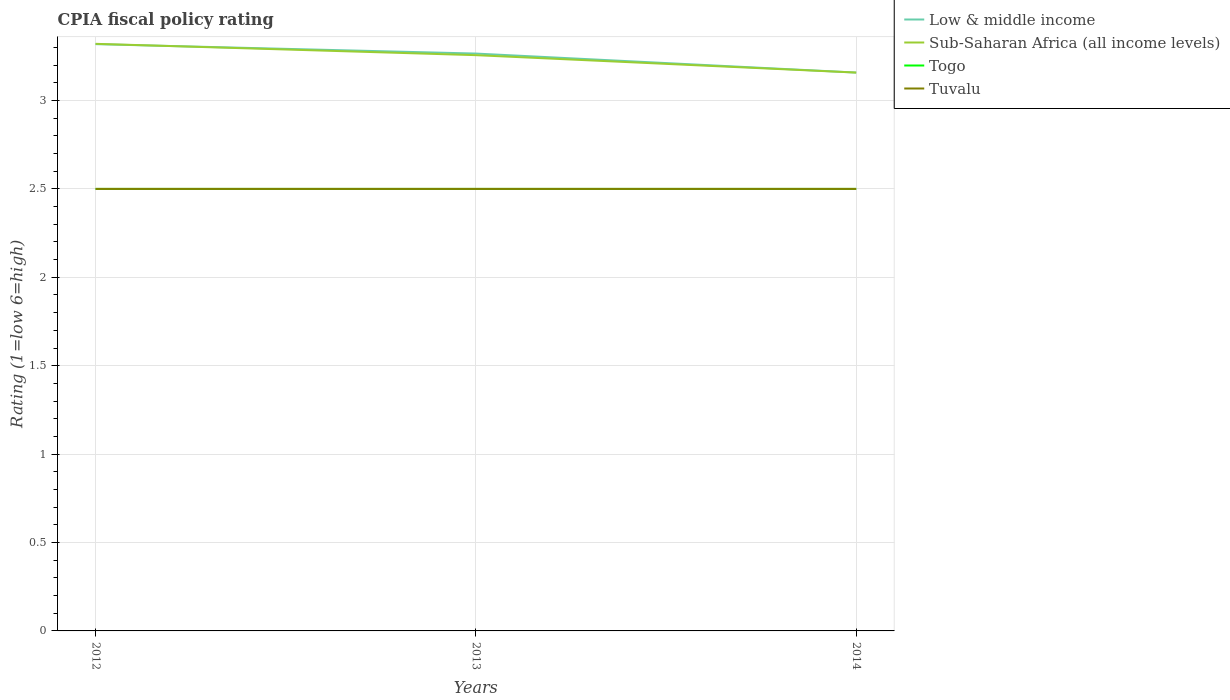Across all years, what is the maximum CPIA rating in Sub-Saharan Africa (all income levels)?
Give a very brief answer. 3.16. In which year was the CPIA rating in Low & middle income maximum?
Your answer should be very brief. 2014. What is the total CPIA rating in Togo in the graph?
Make the answer very short. 0. What is the difference between the highest and the second highest CPIA rating in Low & middle income?
Provide a short and direct response. 0.16. What is the difference between the highest and the lowest CPIA rating in Low & middle income?
Offer a very short reply. 2. How many lines are there?
Provide a succinct answer. 4. How many years are there in the graph?
Keep it short and to the point. 3. Are the values on the major ticks of Y-axis written in scientific E-notation?
Your answer should be compact. No. Does the graph contain grids?
Give a very brief answer. Yes. How many legend labels are there?
Ensure brevity in your answer.  4. What is the title of the graph?
Your answer should be compact. CPIA fiscal policy rating. What is the label or title of the Y-axis?
Your answer should be compact. Rating (1=low 6=high). What is the Rating (1=low 6=high) in Low & middle income in 2012?
Your response must be concise. 3.32. What is the Rating (1=low 6=high) in Sub-Saharan Africa (all income levels) in 2012?
Your answer should be very brief. 3.32. What is the Rating (1=low 6=high) in Tuvalu in 2012?
Your answer should be very brief. 2.5. What is the Rating (1=low 6=high) in Low & middle income in 2013?
Your answer should be very brief. 3.27. What is the Rating (1=low 6=high) in Sub-Saharan Africa (all income levels) in 2013?
Provide a short and direct response. 3.26. What is the Rating (1=low 6=high) in Togo in 2013?
Give a very brief answer. 2.5. What is the Rating (1=low 6=high) of Tuvalu in 2013?
Provide a short and direct response. 2.5. What is the Rating (1=low 6=high) of Low & middle income in 2014?
Keep it short and to the point. 3.16. What is the Rating (1=low 6=high) of Sub-Saharan Africa (all income levels) in 2014?
Provide a succinct answer. 3.16. What is the Rating (1=low 6=high) in Tuvalu in 2014?
Keep it short and to the point. 2.5. Across all years, what is the maximum Rating (1=low 6=high) in Low & middle income?
Provide a succinct answer. 3.32. Across all years, what is the maximum Rating (1=low 6=high) of Sub-Saharan Africa (all income levels)?
Your response must be concise. 3.32. Across all years, what is the maximum Rating (1=low 6=high) of Tuvalu?
Ensure brevity in your answer.  2.5. Across all years, what is the minimum Rating (1=low 6=high) in Low & middle income?
Give a very brief answer. 3.16. Across all years, what is the minimum Rating (1=low 6=high) of Sub-Saharan Africa (all income levels)?
Your answer should be compact. 3.16. What is the total Rating (1=low 6=high) of Low & middle income in the graph?
Make the answer very short. 9.74. What is the total Rating (1=low 6=high) in Sub-Saharan Africa (all income levels) in the graph?
Offer a terse response. 9.73. What is the total Rating (1=low 6=high) in Tuvalu in the graph?
Provide a short and direct response. 7.5. What is the difference between the Rating (1=low 6=high) in Low & middle income in 2012 and that in 2013?
Keep it short and to the point. 0.05. What is the difference between the Rating (1=low 6=high) of Sub-Saharan Africa (all income levels) in 2012 and that in 2013?
Make the answer very short. 0.06. What is the difference between the Rating (1=low 6=high) in Togo in 2012 and that in 2013?
Your answer should be compact. 0. What is the difference between the Rating (1=low 6=high) of Low & middle income in 2012 and that in 2014?
Provide a short and direct response. 0.16. What is the difference between the Rating (1=low 6=high) of Sub-Saharan Africa (all income levels) in 2012 and that in 2014?
Make the answer very short. 0.16. What is the difference between the Rating (1=low 6=high) in Low & middle income in 2013 and that in 2014?
Make the answer very short. 0.11. What is the difference between the Rating (1=low 6=high) in Sub-Saharan Africa (all income levels) in 2013 and that in 2014?
Offer a very short reply. 0.1. What is the difference between the Rating (1=low 6=high) in Togo in 2013 and that in 2014?
Provide a short and direct response. 0. What is the difference between the Rating (1=low 6=high) of Low & middle income in 2012 and the Rating (1=low 6=high) of Sub-Saharan Africa (all income levels) in 2013?
Provide a short and direct response. 0.06. What is the difference between the Rating (1=low 6=high) in Low & middle income in 2012 and the Rating (1=low 6=high) in Togo in 2013?
Give a very brief answer. 0.82. What is the difference between the Rating (1=low 6=high) in Low & middle income in 2012 and the Rating (1=low 6=high) in Tuvalu in 2013?
Your answer should be very brief. 0.82. What is the difference between the Rating (1=low 6=high) of Sub-Saharan Africa (all income levels) in 2012 and the Rating (1=low 6=high) of Togo in 2013?
Offer a very short reply. 0.82. What is the difference between the Rating (1=low 6=high) in Sub-Saharan Africa (all income levels) in 2012 and the Rating (1=low 6=high) in Tuvalu in 2013?
Keep it short and to the point. 0.82. What is the difference between the Rating (1=low 6=high) of Togo in 2012 and the Rating (1=low 6=high) of Tuvalu in 2013?
Give a very brief answer. 0. What is the difference between the Rating (1=low 6=high) of Low & middle income in 2012 and the Rating (1=low 6=high) of Sub-Saharan Africa (all income levels) in 2014?
Make the answer very short. 0.16. What is the difference between the Rating (1=low 6=high) in Low & middle income in 2012 and the Rating (1=low 6=high) in Togo in 2014?
Provide a short and direct response. 0.82. What is the difference between the Rating (1=low 6=high) of Low & middle income in 2012 and the Rating (1=low 6=high) of Tuvalu in 2014?
Give a very brief answer. 0.82. What is the difference between the Rating (1=low 6=high) in Sub-Saharan Africa (all income levels) in 2012 and the Rating (1=low 6=high) in Togo in 2014?
Ensure brevity in your answer.  0.82. What is the difference between the Rating (1=low 6=high) of Sub-Saharan Africa (all income levels) in 2012 and the Rating (1=low 6=high) of Tuvalu in 2014?
Provide a succinct answer. 0.82. What is the difference between the Rating (1=low 6=high) of Low & middle income in 2013 and the Rating (1=low 6=high) of Sub-Saharan Africa (all income levels) in 2014?
Give a very brief answer. 0.11. What is the difference between the Rating (1=low 6=high) of Low & middle income in 2013 and the Rating (1=low 6=high) of Togo in 2014?
Give a very brief answer. 0.77. What is the difference between the Rating (1=low 6=high) of Low & middle income in 2013 and the Rating (1=low 6=high) of Tuvalu in 2014?
Give a very brief answer. 0.77. What is the difference between the Rating (1=low 6=high) in Sub-Saharan Africa (all income levels) in 2013 and the Rating (1=low 6=high) in Togo in 2014?
Offer a terse response. 0.76. What is the difference between the Rating (1=low 6=high) of Sub-Saharan Africa (all income levels) in 2013 and the Rating (1=low 6=high) of Tuvalu in 2014?
Your answer should be very brief. 0.76. What is the difference between the Rating (1=low 6=high) in Togo in 2013 and the Rating (1=low 6=high) in Tuvalu in 2014?
Your answer should be very brief. 0. What is the average Rating (1=low 6=high) in Low & middle income per year?
Your response must be concise. 3.25. What is the average Rating (1=low 6=high) of Sub-Saharan Africa (all income levels) per year?
Your answer should be very brief. 3.24. What is the average Rating (1=low 6=high) of Togo per year?
Provide a short and direct response. 2.5. In the year 2012, what is the difference between the Rating (1=low 6=high) of Low & middle income and Rating (1=low 6=high) of Sub-Saharan Africa (all income levels)?
Provide a short and direct response. -0. In the year 2012, what is the difference between the Rating (1=low 6=high) in Low & middle income and Rating (1=low 6=high) in Togo?
Your response must be concise. 0.82. In the year 2012, what is the difference between the Rating (1=low 6=high) in Low & middle income and Rating (1=low 6=high) in Tuvalu?
Provide a short and direct response. 0.82. In the year 2012, what is the difference between the Rating (1=low 6=high) in Sub-Saharan Africa (all income levels) and Rating (1=low 6=high) in Togo?
Offer a terse response. 0.82. In the year 2012, what is the difference between the Rating (1=low 6=high) in Sub-Saharan Africa (all income levels) and Rating (1=low 6=high) in Tuvalu?
Provide a succinct answer. 0.82. In the year 2012, what is the difference between the Rating (1=low 6=high) in Togo and Rating (1=low 6=high) in Tuvalu?
Your answer should be very brief. 0. In the year 2013, what is the difference between the Rating (1=low 6=high) in Low & middle income and Rating (1=low 6=high) in Sub-Saharan Africa (all income levels)?
Provide a succinct answer. 0.01. In the year 2013, what is the difference between the Rating (1=low 6=high) of Low & middle income and Rating (1=low 6=high) of Togo?
Provide a short and direct response. 0.77. In the year 2013, what is the difference between the Rating (1=low 6=high) in Low & middle income and Rating (1=low 6=high) in Tuvalu?
Make the answer very short. 0.77. In the year 2013, what is the difference between the Rating (1=low 6=high) in Sub-Saharan Africa (all income levels) and Rating (1=low 6=high) in Togo?
Keep it short and to the point. 0.76. In the year 2013, what is the difference between the Rating (1=low 6=high) in Sub-Saharan Africa (all income levels) and Rating (1=low 6=high) in Tuvalu?
Your answer should be very brief. 0.76. In the year 2014, what is the difference between the Rating (1=low 6=high) of Low & middle income and Rating (1=low 6=high) of Togo?
Make the answer very short. 0.66. In the year 2014, what is the difference between the Rating (1=low 6=high) of Low & middle income and Rating (1=low 6=high) of Tuvalu?
Offer a very short reply. 0.66. In the year 2014, what is the difference between the Rating (1=low 6=high) in Sub-Saharan Africa (all income levels) and Rating (1=low 6=high) in Togo?
Offer a terse response. 0.66. In the year 2014, what is the difference between the Rating (1=low 6=high) in Sub-Saharan Africa (all income levels) and Rating (1=low 6=high) in Tuvalu?
Keep it short and to the point. 0.66. In the year 2014, what is the difference between the Rating (1=low 6=high) in Togo and Rating (1=low 6=high) in Tuvalu?
Your response must be concise. 0. What is the ratio of the Rating (1=low 6=high) of Low & middle income in 2012 to that in 2013?
Offer a terse response. 1.02. What is the ratio of the Rating (1=low 6=high) of Sub-Saharan Africa (all income levels) in 2012 to that in 2013?
Provide a short and direct response. 1.02. What is the ratio of the Rating (1=low 6=high) in Low & middle income in 2012 to that in 2014?
Provide a short and direct response. 1.05. What is the ratio of the Rating (1=low 6=high) of Sub-Saharan Africa (all income levels) in 2012 to that in 2014?
Provide a short and direct response. 1.05. What is the ratio of the Rating (1=low 6=high) in Togo in 2012 to that in 2014?
Your answer should be compact. 1. What is the ratio of the Rating (1=low 6=high) of Low & middle income in 2013 to that in 2014?
Provide a short and direct response. 1.03. What is the ratio of the Rating (1=low 6=high) of Sub-Saharan Africa (all income levels) in 2013 to that in 2014?
Give a very brief answer. 1.03. What is the difference between the highest and the second highest Rating (1=low 6=high) in Low & middle income?
Your response must be concise. 0.05. What is the difference between the highest and the second highest Rating (1=low 6=high) in Sub-Saharan Africa (all income levels)?
Ensure brevity in your answer.  0.06. What is the difference between the highest and the second highest Rating (1=low 6=high) in Tuvalu?
Provide a succinct answer. 0. What is the difference between the highest and the lowest Rating (1=low 6=high) in Low & middle income?
Your answer should be compact. 0.16. What is the difference between the highest and the lowest Rating (1=low 6=high) in Sub-Saharan Africa (all income levels)?
Make the answer very short. 0.16. What is the difference between the highest and the lowest Rating (1=low 6=high) in Togo?
Ensure brevity in your answer.  0. 